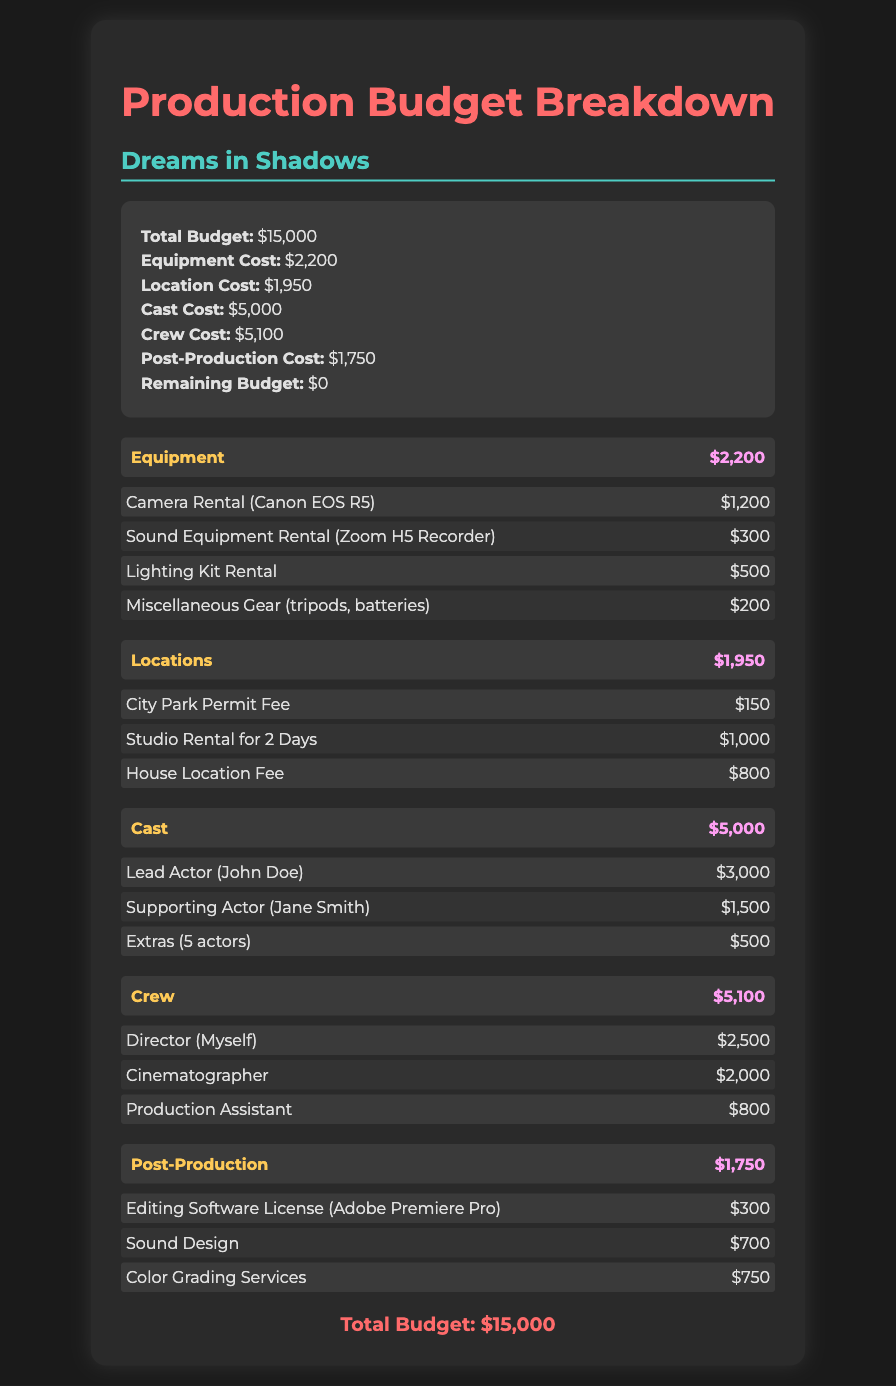what is the total budget? The total budget is listed at the top of the document summary, which is $15,000.
Answer: $15,000 how much was spent on cast? The cost for the cast is detailed in the summary as $5,000.
Answer: $5,000 who is the lead actor? The lead actor is mentioned in the cast breakdown as John Doe.
Answer: John Doe what was the cost for post-production? The post-production costs are outlined in the summary as $1,750.
Answer: $1,750 which equipment cost the most? The most expensive item under equipment is the Camera Rental (Canon EOS R5) for $1,200.
Answer: Camera Rental (Canon EOS R5) how much did crew expenses total? Crew expenses are detailed in the summary as $5,100.
Answer: $5,100 what is the permit fee for the city park? The City Park Permit Fee is listed under locations as $150.
Answer: $150 how many extras were included in the cast? The extras are mentioned as 5 actors in the cast breakdown.
Answer: 5 actors what editing software license was purchased? The editing software license specified in the post-production section is Adobe Premiere Pro.
Answer: Adobe Premiere Pro 